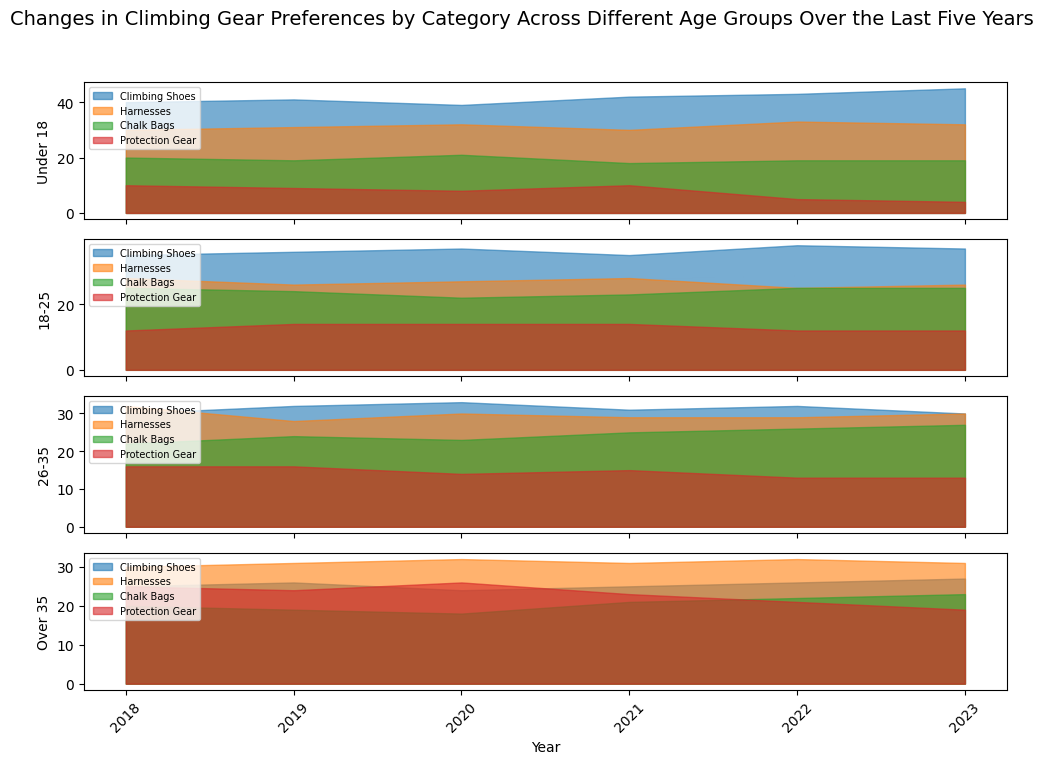What is the overall trend for climbing shoes preference among the 'Under 18' age group from 2018 to 2023? Visually observe the area chart dedicated to the 'Under 18' age group. Focus on the section for climbing shoes. Notice that the preference values increase progressively from 2018 to 2023.
Answer: Increasing Between 2018 and 2023, which age group saw the least preference for protection gear in 2023? Look at the preferences for protection gear across all age groups in the year 2023. The 'Under 18' age group has the smallest area representing protection gear in 2023.
Answer: Under 18 How does the preference for chalk bags in the 'Over 35' age group change from 2021 to 2023? Observe the specific area for chalk bags in the 'Over 35' age group from 2021 to 2023. You will see that the area is increasing gradually indicating an increase in preference.
Answer: Increasing Comparing 2020 and 2022, which age group experienced the most significant decrease in preference for protection gear? Analyze the protection gear areas for each age group between 2020 and 2022. The 'Under 18' age group shows the most noticeable decrease in the area for protection gear.
Answer: Under 18 What is the combined preference for climbing shoes and harnesses in the '18-25' age group in 2023? Sum the preference values for climbing shoes and harnesses for the '18-25' age group in 2023. Climbing Shoes: 37, Harnesses: 26. Combined: 37 + 26 = 63
Answer: 63 Which category and age group combination had the highest preference in 2021? Scan through all age groups and categories for the year 2021. Notice the highest peak or largest area. Under 'Under 18', climbing shoes have the highest preference.
Answer: Climbing shoes, Under 18 By comparing the preferences for harnesses across all age groups in 2020, which group showed the highest preference? Look at the height of the filled areas for harnesses across all age groups for the year 2020. The 'Over 35' age group shows the highest area.
Answer: Over 35 What is the difference in the preference for chalk bags between 2018 and 2023 for the '26-35' age group? Identify the values for chalk bags in the '26-35' age group for the years 2018 and 2023. For 2018: 22, and for 2023: 27. The difference is 27 - 22 = 5.
Answer: 5 